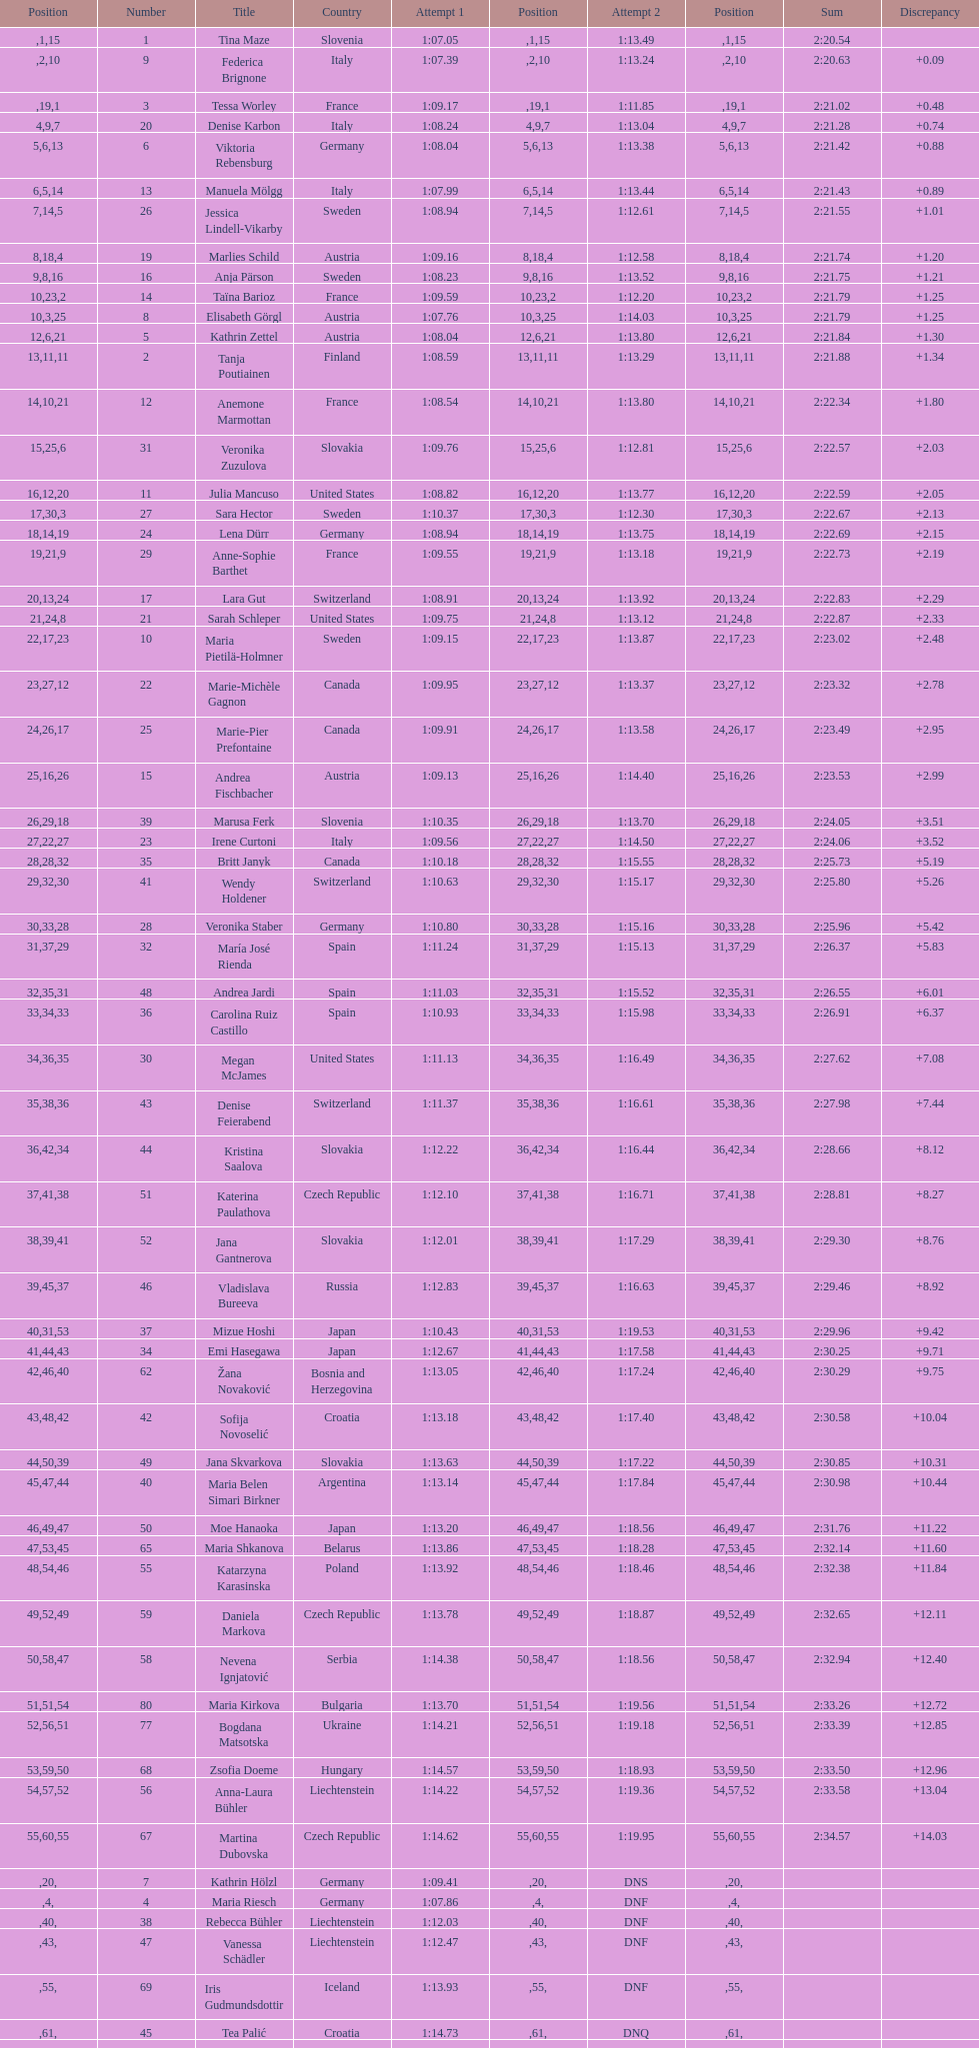Who ranked next after federica brignone? Tessa Worley. 